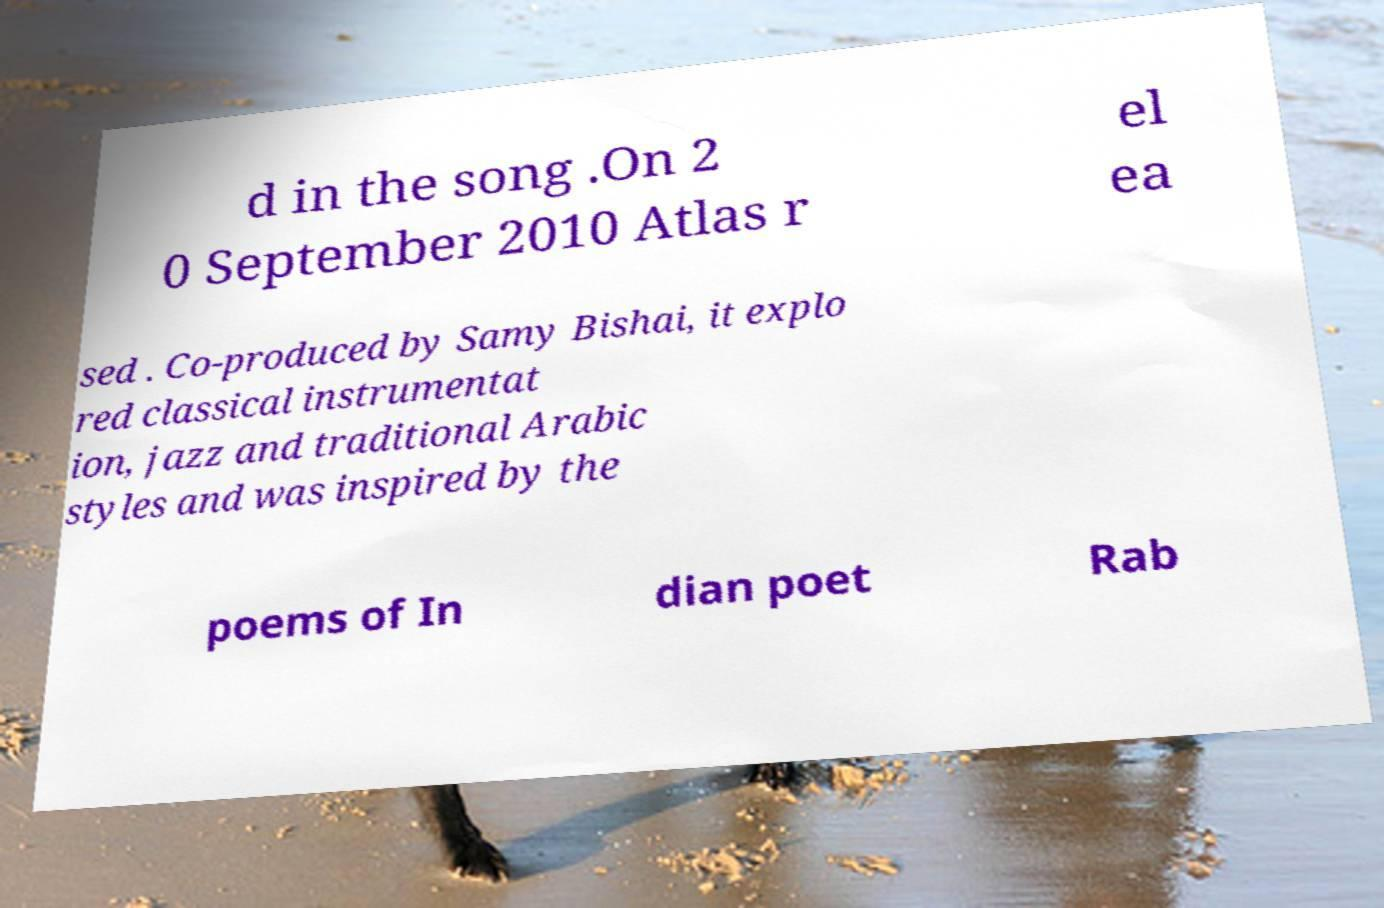There's text embedded in this image that I need extracted. Can you transcribe it verbatim? d in the song .On 2 0 September 2010 Atlas r el ea sed . Co-produced by Samy Bishai, it explo red classical instrumentat ion, jazz and traditional Arabic styles and was inspired by the poems of In dian poet Rab 